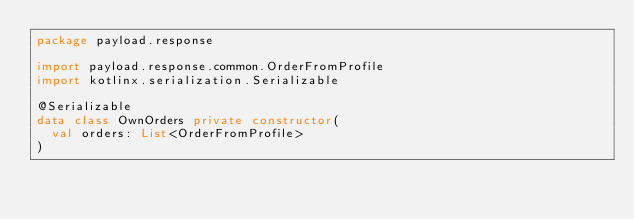Convert code to text. <code><loc_0><loc_0><loc_500><loc_500><_Kotlin_>package payload.response

import payload.response.common.OrderFromProfile
import kotlinx.serialization.Serializable

@Serializable
data class OwnOrders private constructor(
	val orders: List<OrderFromProfile>
)</code> 